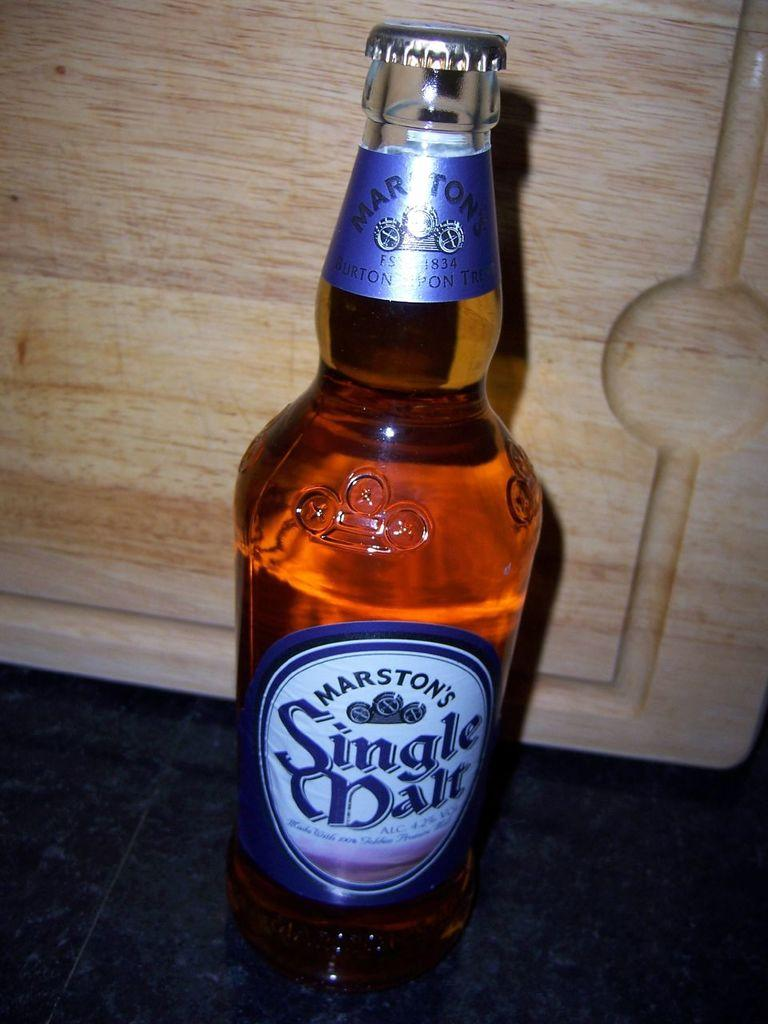Provide a one-sentence caption for the provided image. A glass of beer, marston's sangle mate, the cap is still on. 